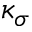Convert formula to latex. <formula><loc_0><loc_0><loc_500><loc_500>\kappa _ { \sigma }</formula> 